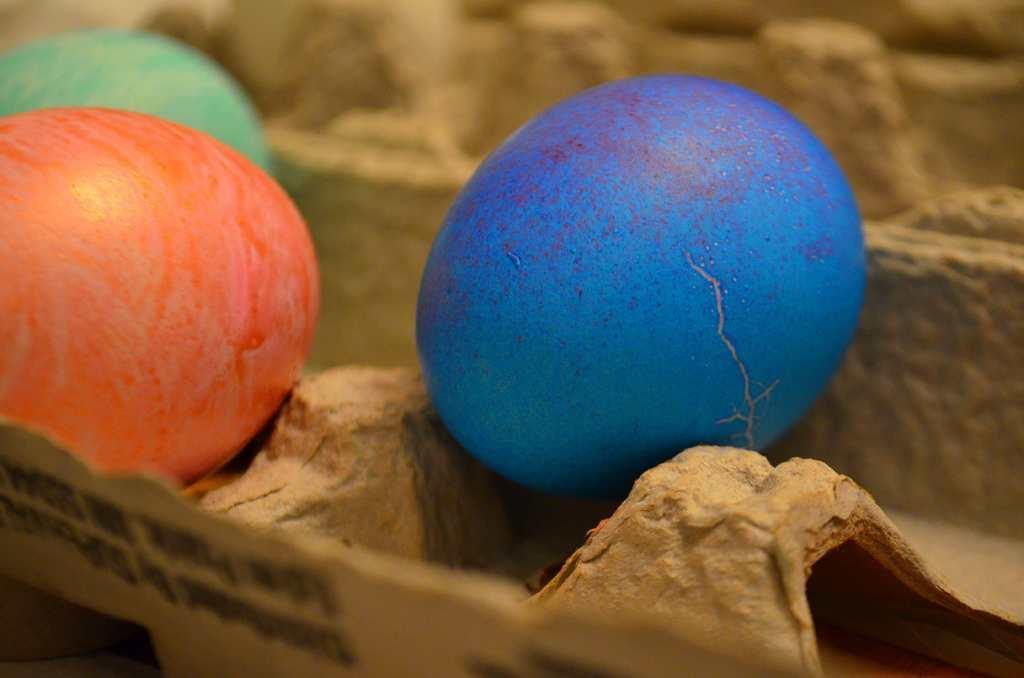In one or two sentences, can you explain what this image depicts? There are three eggs in green, orange and blue color placed on the egg tray. 